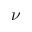Convert formula to latex. <formula><loc_0><loc_0><loc_500><loc_500>\nu</formula> 